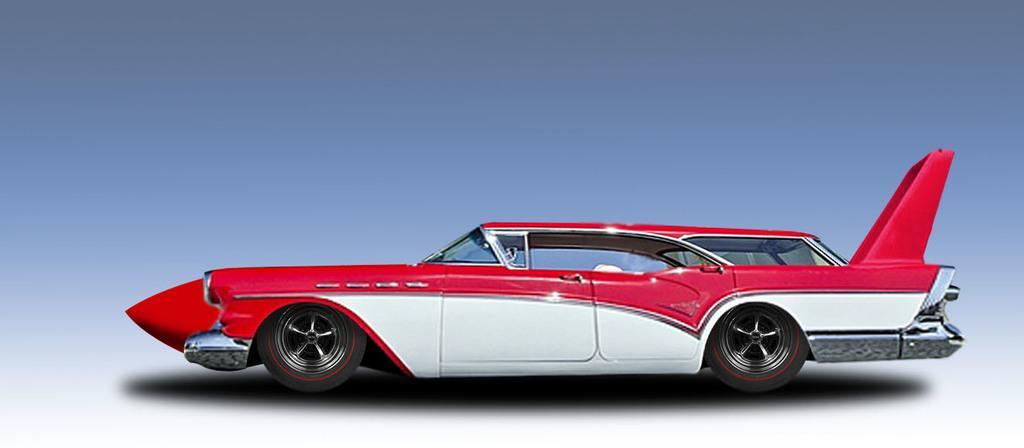How would you summarize this image in a sentence or two? In the image there is a toy car, it is of white and red color. 